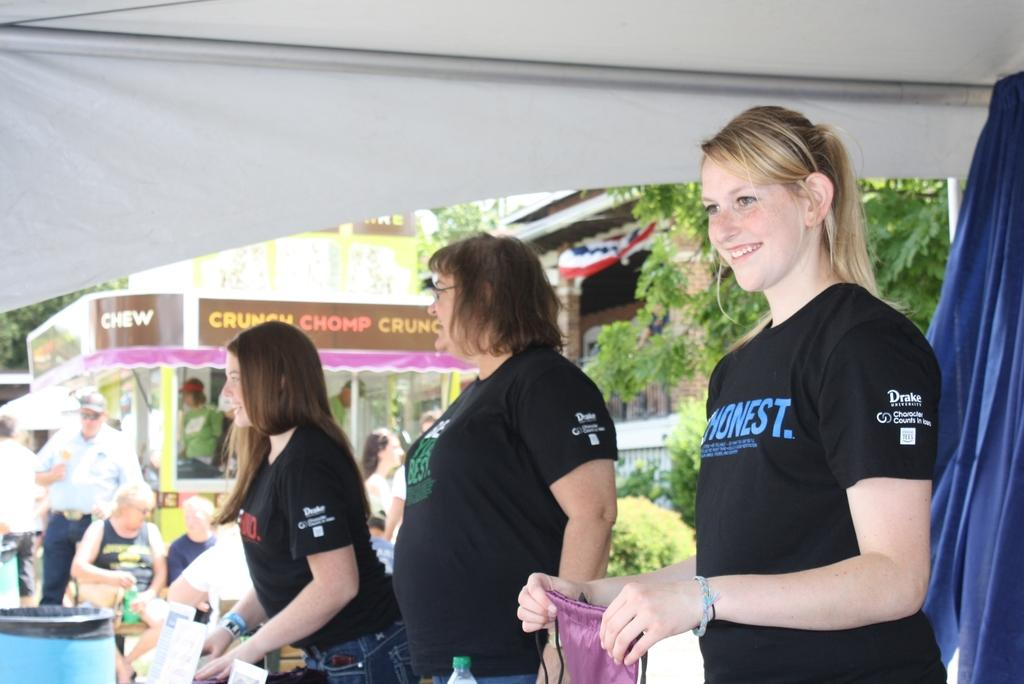What is happening on the road in the image? There is a crowd on the road in the image. What can be seen inside a structure in the image? There is a curtain visible in the image. What type of temporary shelter is present in the image? There is a tent in the image. What types of transportation are present in the image? There are vehicles in the image. What type of vegetation is present in the image? There are trees in the image. What type of man-made structure is present in the image? There is a building in the image. What time of day was the image likely taken? The image was likely taken during the day, as there is no indication of darkness or artificial lighting. What type of yoke can be seen being used by the crowd in the image? There is no yoke present in the image, and the crowd is not using any such object. How many letters are visible on the building in the image? There is no indication of any letters or text on the building in the image. 